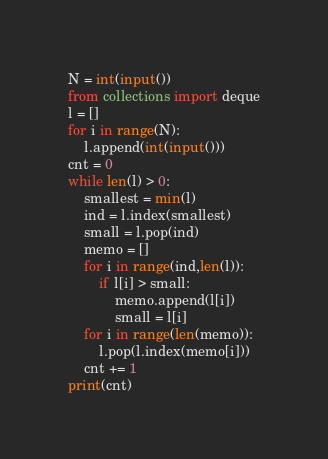Convert code to text. <code><loc_0><loc_0><loc_500><loc_500><_Python_>N = int(input())
from collections import deque
l = []
for i in range(N):
    l.append(int(input()))
cnt = 0
while len(l) > 0:
    smallest = min(l)
    ind = l.index(smallest)
    small = l.pop(ind)
    memo = []
    for i in range(ind,len(l)):
        if l[i] > small:
            memo.append(l[i])
            small = l[i]
    for i in range(len(memo)):
        l.pop(l.index(memo[i]))
    cnt += 1
print(cnt)</code> 